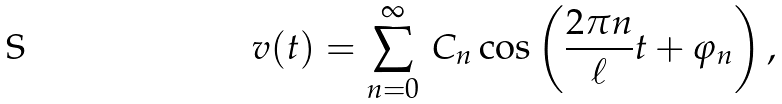Convert formula to latex. <formula><loc_0><loc_0><loc_500><loc_500>v ( t ) = \sum _ { n = 0 } ^ { \infty } \, C _ { n } \cos \left ( \frac { 2 \pi n } { \ell } t + \varphi _ { n } \right ) ,</formula> 